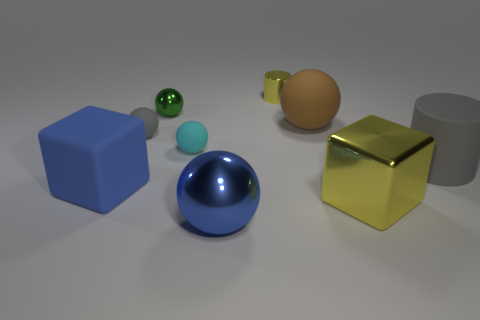What can you infer about the source of light in this scene? From the shadows and highlights on the objects, we can infer that the primary light source is located above and slightly to the right of the scene. The shadows are soft and diffuse, suggesting the light source could be large or there may be some form of diffusion, like a cloudy day or studio lighting with a softbox. The lack of multiple hard-edged shadows indicates there's likely just one main light source illuminating the scene. 